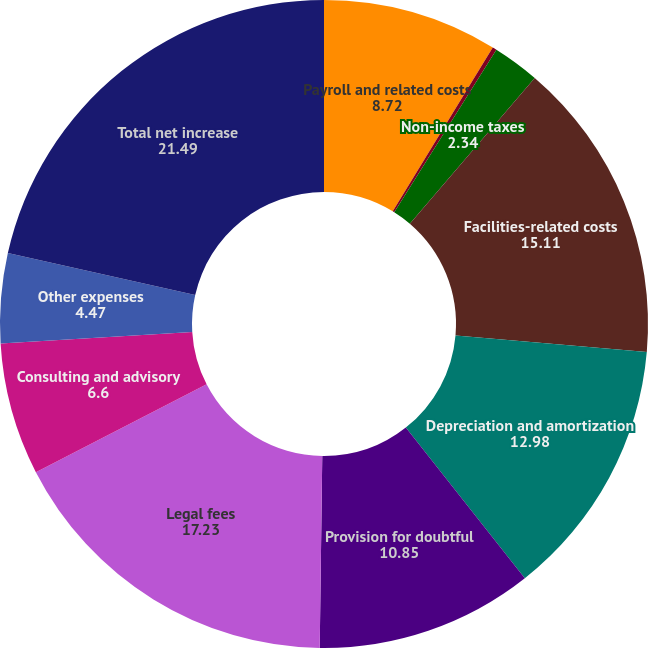<chart> <loc_0><loc_0><loc_500><loc_500><pie_chart><fcel>Payroll and related costs<fcel>Stock-based compensation<fcel>Non-income taxes<fcel>Facilities-related costs<fcel>Depreciation and amortization<fcel>Provision for doubtful<fcel>Legal fees<fcel>Consulting and advisory<fcel>Other expenses<fcel>Total net increase<nl><fcel>8.72%<fcel>0.21%<fcel>2.34%<fcel>15.11%<fcel>12.98%<fcel>10.85%<fcel>17.23%<fcel>6.6%<fcel>4.47%<fcel>21.49%<nl></chart> 